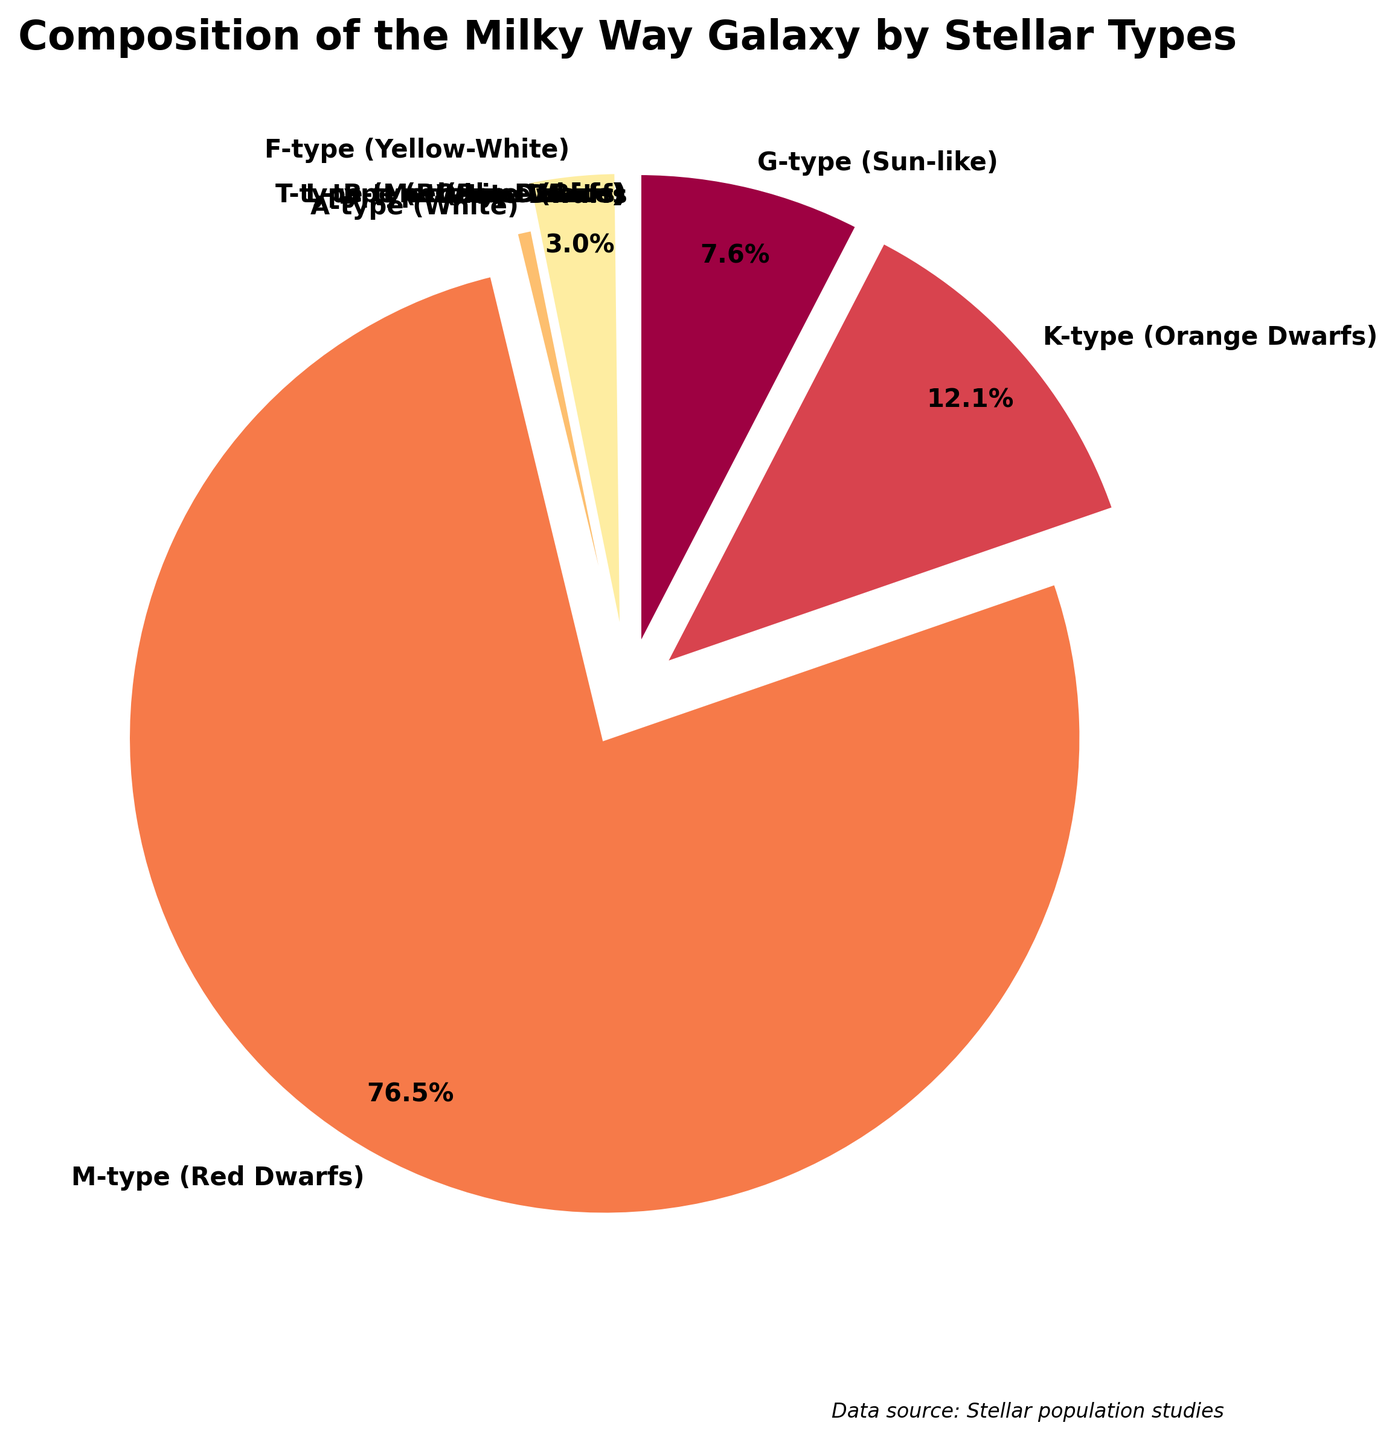What's the percentage of M-type (Red Dwarfs) and G-type (Sun-like) stars combined? According to the figure, M-type (Red Dwarfs) stars make up 76.5% and G-type (Sun-like) stars make up 7.6%. Summing these percentages: 76.5% + 7.6% = 84.1%.
Answer: 84.1% Which stellar type has the smallest percentage in the Milky Way galaxy? The figure shows various stellar types with their respective percentages. O-type (Blue) stars have the smallest percentage at 0.00003%.
Answer: O-type (Blue) What is the difference in percentage between K-type (Orange Dwarfs) and F-type (Yellow-White) stars? K-type (Orange Dwarfs) stars represent 12.1%, while F-type (Yellow-White) stars represent 3.0%. The difference in percentages is 12.1% - 3.0% = 9.1%.
Answer: 9.1% Which two stellar types combined account for less than 1% of the galaxy? The chart lists several types with low percentages. Adding the percentages of O-type (0.00003%) and White Dwarfs (0.007%), we get 0.00003% + 0.007% = 0.00703%, which is less than 1%. Another pair is T-type (0.05%) and L-type (0.03%), summing to 0.08%, also less than 1%.
Answer: O-type and White Dwarfs Which stellar types have a percentage greater than 10%? From the chart, the types with percentages greater than 10% are M-type (Red Dwarfs) at 76.5% and K-type (Orange Dwarfs) at 12.1%.
Answer: M-type and K-type What's the total percentage of all stellar types that are not dwarfs? Excluding G-type, K-type, M-type, L-type, and T-type, we look at A-type (0.6%), F-type (3.0%), B-type (0.1%), O-type (0.00003%), and White Dwarfs (0.007%). Summing these: 0.6% + 3.0% + 0.1% + 0.00003% + 0.007% = 3.70703%.
Answer: 3.70703% Which color represents the largest stellar type group in the chart? The largest group, M-type (Red Dwarfs), likely uses one of the more prominent, noticeable colors in the spectrum shown (often red).
Answer: Red What is the visual difference between slices representing A-type (White) and B-type (Blue-White) stars? Observing the chart, the slice for A-type (White) stars is larger in both area and highlighted with a label, while the B-type (Blue-White) stars are much smaller and less noticeable.
Answer: A-type is larger How many stellar types have a visual slice that is not labeled due to its small percentage? Observing the chart, it is clear that O-type (Blue), L-type (Brown Dwarfs), T-type (Methane Dwarfs), and White Dwarfs are not labeled as their percentages are smaller than 1%.
Answer: 4 